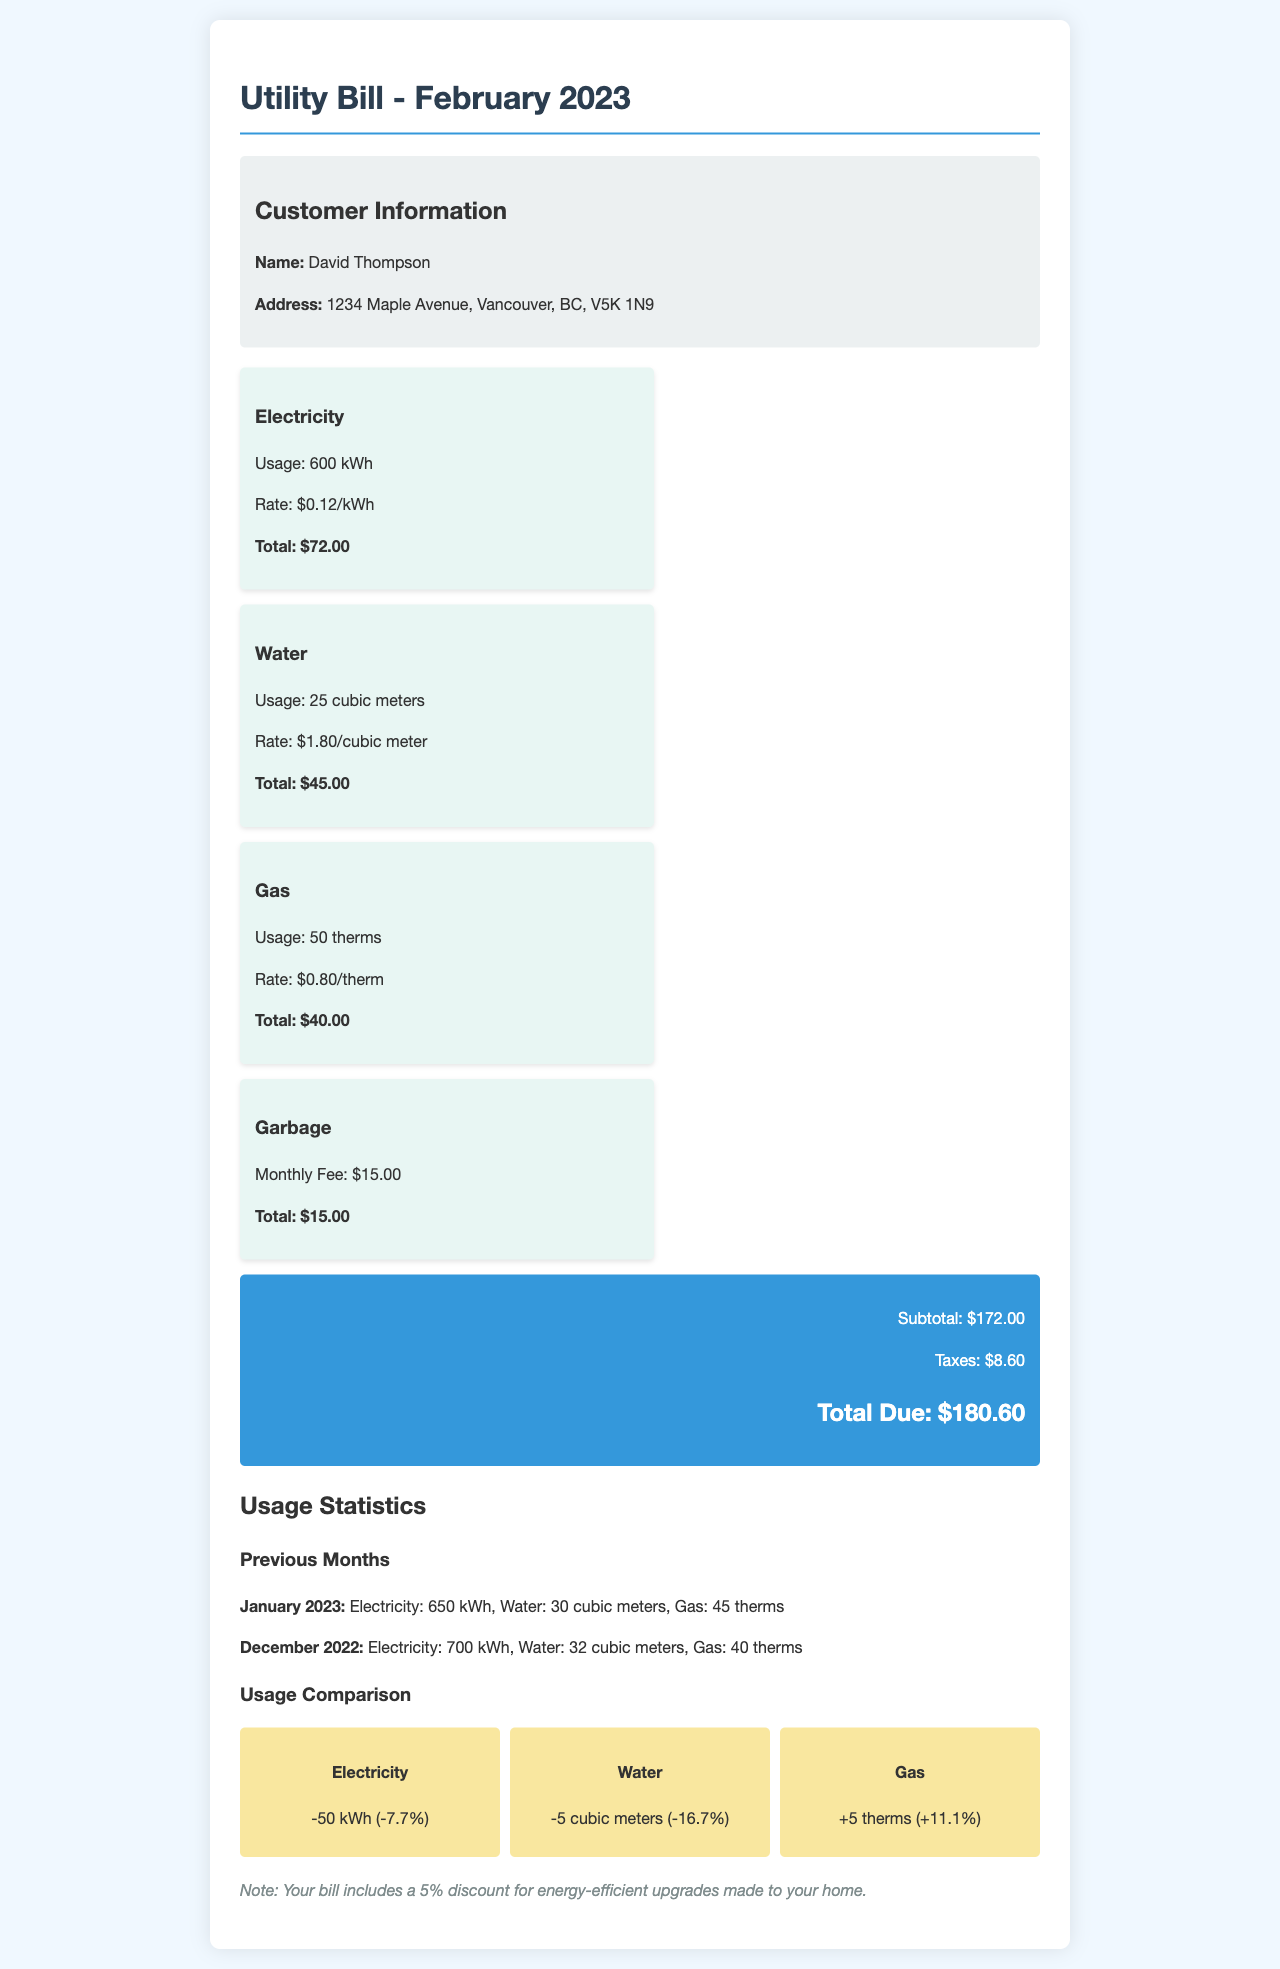What is the total due for February 2023? The total due is the final amount listed at the bottom of the bill, which is the sum of the subtotal and taxes.
Answer: $180.60 How much was the water usage in February 2023? The water usage is specified in the charges section of the document and is measured in cubic meters.
Answer: 25 cubic meters What was the electricity rate per kWh? The rate for electricity is provided alongside the usage and total charges, expressed in dollars per kilowatt-hour.
Answer: $0.12/kWh Was there a change in gas usage compared to January 2023? The document provides a comparison of gas usage between February and January, indicating if it increased or decreased.
Answer: +5 therms What is the monthly fee for garbage services? The monthly fee for garbage services is indicated separately in the charges section as a fixed amount.
Answer: $15.00 What discount is applied to this bill? The document mentions a specific discount applied for a certain reason.
Answer: 5% discount for energy-efficient upgrades How much was the tax amount for February 2023? The tax amount is clearly stated in the total calculations within the document.
Answer: $8.60 What was the electricity usage in January 2023? The document provides previous months' usage statistics, specifically for electricity in January.
Answer: 650 kWh What percentage did the water usage decrease compared to January 2023? The document includes a comparison of the water usage between February and January with the corresponding percentage change.
Answer: -16.7% 